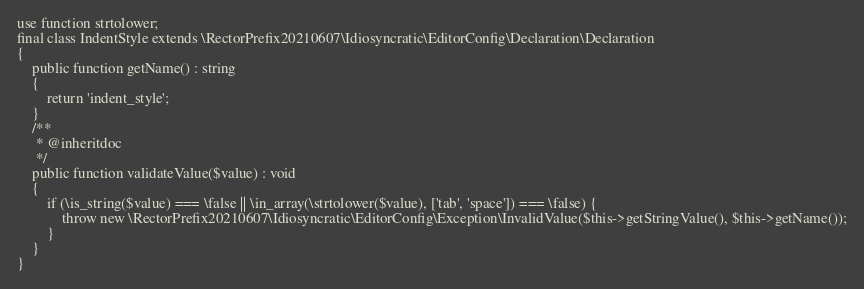<code> <loc_0><loc_0><loc_500><loc_500><_PHP_>use function strtolower;
final class IndentStyle extends \RectorPrefix20210607\Idiosyncratic\EditorConfig\Declaration\Declaration
{
    public function getName() : string
    {
        return 'indent_style';
    }
    /**
     * @inheritdoc
     */
    public function validateValue($value) : void
    {
        if (\is_string($value) === \false || \in_array(\strtolower($value), ['tab', 'space']) === \false) {
            throw new \RectorPrefix20210607\Idiosyncratic\EditorConfig\Exception\InvalidValue($this->getStringValue(), $this->getName());
        }
    }
}
</code> 